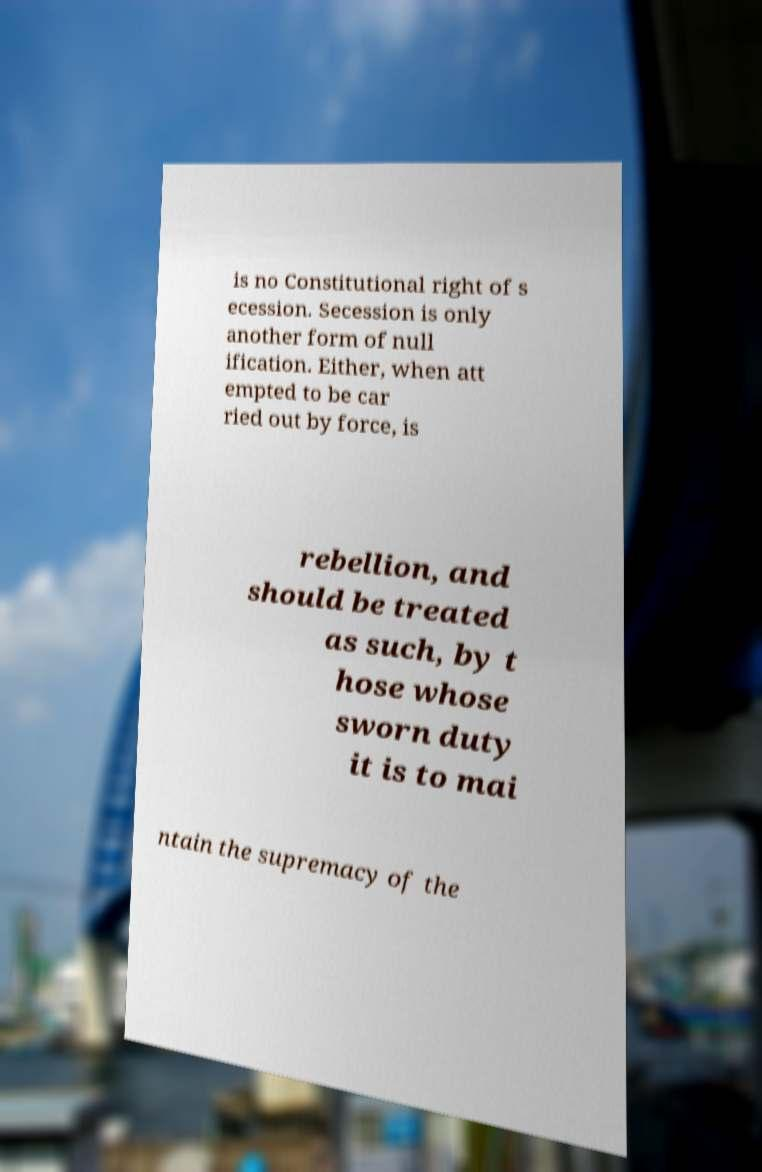What messages or text are displayed in this image? I need them in a readable, typed format. is no Constitutional right of s ecession. Secession is only another form of null ification. Either, when att empted to be car ried out by force, is rebellion, and should be treated as such, by t hose whose sworn duty it is to mai ntain the supremacy of the 